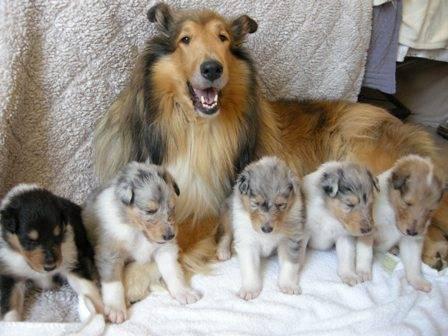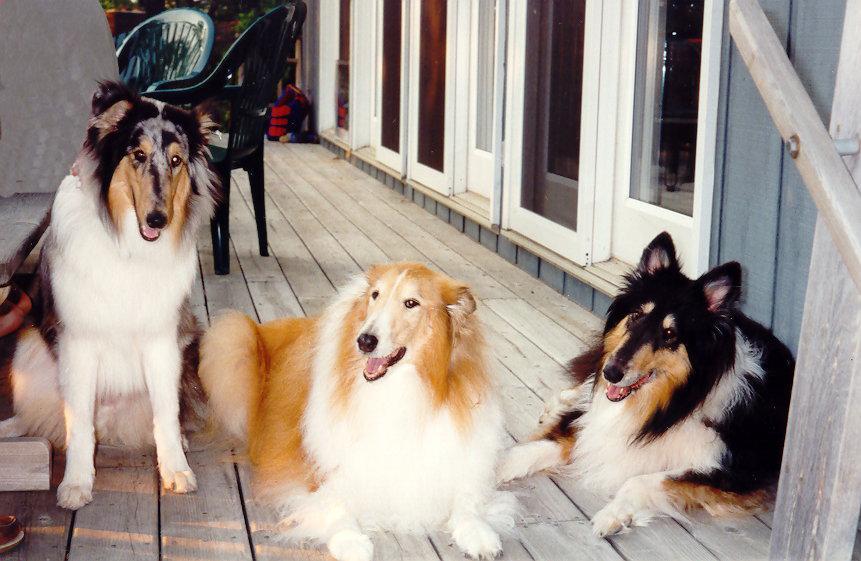The first image is the image on the left, the second image is the image on the right. Analyze the images presented: Is the assertion "Each image contains exactly three dogs." valid? Answer yes or no. No. The first image is the image on the left, the second image is the image on the right. For the images displayed, is the sentence "Three collies pose together in both of the pictures." factually correct? Answer yes or no. No. 